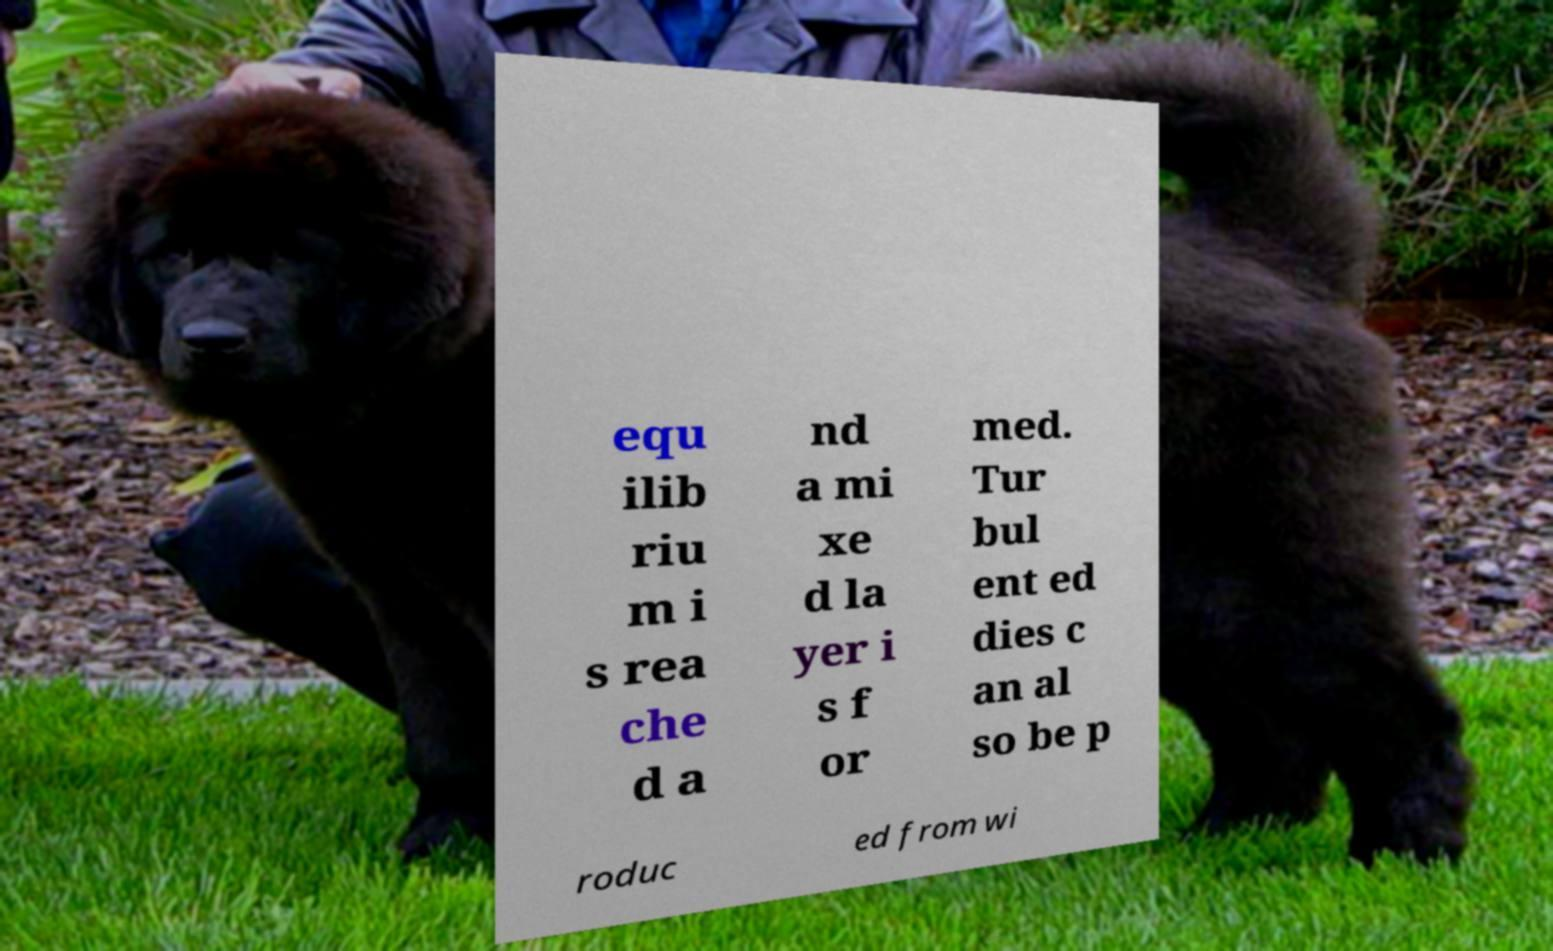I need the written content from this picture converted into text. Can you do that? equ ilib riu m i s rea che d a nd a mi xe d la yer i s f or med. Tur bul ent ed dies c an al so be p roduc ed from wi 